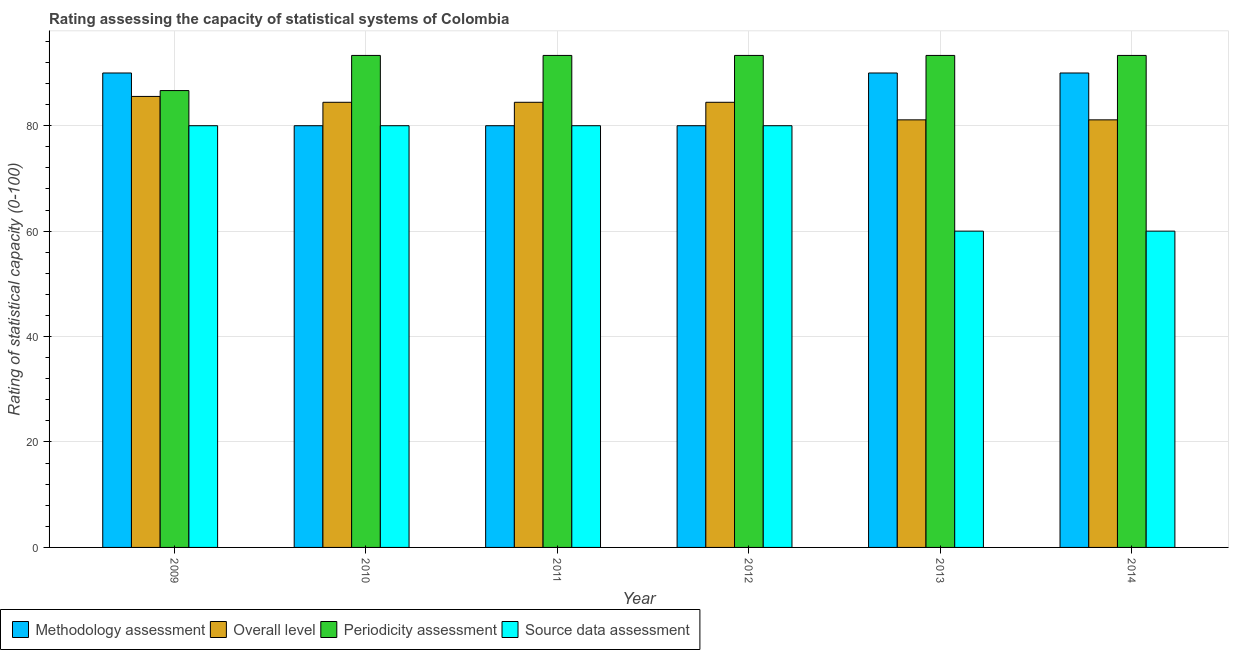How many different coloured bars are there?
Provide a short and direct response. 4. How many groups of bars are there?
Provide a succinct answer. 6. How many bars are there on the 3rd tick from the left?
Your response must be concise. 4. What is the periodicity assessment rating in 2012?
Your answer should be compact. 93.33. Across all years, what is the maximum methodology assessment rating?
Give a very brief answer. 90. Across all years, what is the minimum source data assessment rating?
Offer a very short reply. 60. In which year was the periodicity assessment rating maximum?
Ensure brevity in your answer.  2013. What is the total periodicity assessment rating in the graph?
Keep it short and to the point. 553.33. What is the difference between the overall level rating in 2009 and that in 2011?
Offer a terse response. 1.11. What is the difference between the periodicity assessment rating in 2009 and the methodology assessment rating in 2012?
Ensure brevity in your answer.  -6.67. What is the average source data assessment rating per year?
Offer a terse response. 73.33. What is the ratio of the methodology assessment rating in 2011 to that in 2012?
Your answer should be very brief. 1. Is the periodicity assessment rating in 2010 less than that in 2012?
Your response must be concise. No. Is the difference between the methodology assessment rating in 2013 and 2014 greater than the difference between the overall level rating in 2013 and 2014?
Make the answer very short. No. What is the difference between the highest and the second highest overall level rating?
Give a very brief answer. 1.11. What is the difference between the highest and the lowest periodicity assessment rating?
Make the answer very short. 6.67. In how many years, is the methodology assessment rating greater than the average methodology assessment rating taken over all years?
Provide a short and direct response. 3. Is the sum of the methodology assessment rating in 2010 and 2011 greater than the maximum periodicity assessment rating across all years?
Provide a succinct answer. Yes. Is it the case that in every year, the sum of the overall level rating and methodology assessment rating is greater than the sum of source data assessment rating and periodicity assessment rating?
Your answer should be very brief. No. What does the 1st bar from the left in 2012 represents?
Ensure brevity in your answer.  Methodology assessment. What does the 4th bar from the right in 2012 represents?
Your answer should be very brief. Methodology assessment. Is it the case that in every year, the sum of the methodology assessment rating and overall level rating is greater than the periodicity assessment rating?
Ensure brevity in your answer.  Yes. Are all the bars in the graph horizontal?
Offer a very short reply. No. What is the difference between two consecutive major ticks on the Y-axis?
Give a very brief answer. 20. Are the values on the major ticks of Y-axis written in scientific E-notation?
Provide a succinct answer. No. Does the graph contain any zero values?
Give a very brief answer. No. How many legend labels are there?
Offer a very short reply. 4. What is the title of the graph?
Offer a very short reply. Rating assessing the capacity of statistical systems of Colombia. What is the label or title of the Y-axis?
Ensure brevity in your answer.  Rating of statistical capacity (0-100). What is the Rating of statistical capacity (0-100) of Methodology assessment in 2009?
Keep it short and to the point. 90. What is the Rating of statistical capacity (0-100) of Overall level in 2009?
Offer a very short reply. 85.56. What is the Rating of statistical capacity (0-100) of Periodicity assessment in 2009?
Ensure brevity in your answer.  86.67. What is the Rating of statistical capacity (0-100) in Overall level in 2010?
Keep it short and to the point. 84.44. What is the Rating of statistical capacity (0-100) of Periodicity assessment in 2010?
Your answer should be very brief. 93.33. What is the Rating of statistical capacity (0-100) in Overall level in 2011?
Offer a very short reply. 84.44. What is the Rating of statistical capacity (0-100) in Periodicity assessment in 2011?
Offer a very short reply. 93.33. What is the Rating of statistical capacity (0-100) of Methodology assessment in 2012?
Offer a very short reply. 80. What is the Rating of statistical capacity (0-100) of Overall level in 2012?
Your answer should be compact. 84.44. What is the Rating of statistical capacity (0-100) in Periodicity assessment in 2012?
Ensure brevity in your answer.  93.33. What is the Rating of statistical capacity (0-100) of Overall level in 2013?
Make the answer very short. 81.11. What is the Rating of statistical capacity (0-100) of Periodicity assessment in 2013?
Provide a succinct answer. 93.33. What is the Rating of statistical capacity (0-100) in Source data assessment in 2013?
Make the answer very short. 60. What is the Rating of statistical capacity (0-100) of Methodology assessment in 2014?
Provide a short and direct response. 90. What is the Rating of statistical capacity (0-100) of Overall level in 2014?
Offer a terse response. 81.11. What is the Rating of statistical capacity (0-100) in Periodicity assessment in 2014?
Provide a succinct answer. 93.33. What is the Rating of statistical capacity (0-100) in Source data assessment in 2014?
Make the answer very short. 60. Across all years, what is the maximum Rating of statistical capacity (0-100) in Methodology assessment?
Offer a very short reply. 90. Across all years, what is the maximum Rating of statistical capacity (0-100) in Overall level?
Make the answer very short. 85.56. Across all years, what is the maximum Rating of statistical capacity (0-100) of Periodicity assessment?
Your answer should be compact. 93.33. Across all years, what is the minimum Rating of statistical capacity (0-100) of Methodology assessment?
Your answer should be compact. 80. Across all years, what is the minimum Rating of statistical capacity (0-100) of Overall level?
Provide a short and direct response. 81.11. Across all years, what is the minimum Rating of statistical capacity (0-100) of Periodicity assessment?
Ensure brevity in your answer.  86.67. Across all years, what is the minimum Rating of statistical capacity (0-100) of Source data assessment?
Provide a short and direct response. 60. What is the total Rating of statistical capacity (0-100) of Methodology assessment in the graph?
Make the answer very short. 510. What is the total Rating of statistical capacity (0-100) of Overall level in the graph?
Offer a terse response. 501.11. What is the total Rating of statistical capacity (0-100) in Periodicity assessment in the graph?
Ensure brevity in your answer.  553.33. What is the total Rating of statistical capacity (0-100) of Source data assessment in the graph?
Keep it short and to the point. 440. What is the difference between the Rating of statistical capacity (0-100) of Periodicity assessment in 2009 and that in 2010?
Give a very brief answer. -6.67. What is the difference between the Rating of statistical capacity (0-100) in Periodicity assessment in 2009 and that in 2011?
Provide a succinct answer. -6.67. What is the difference between the Rating of statistical capacity (0-100) of Periodicity assessment in 2009 and that in 2012?
Your answer should be compact. -6.67. What is the difference between the Rating of statistical capacity (0-100) of Source data assessment in 2009 and that in 2012?
Provide a succinct answer. 0. What is the difference between the Rating of statistical capacity (0-100) of Methodology assessment in 2009 and that in 2013?
Keep it short and to the point. 0. What is the difference between the Rating of statistical capacity (0-100) of Overall level in 2009 and that in 2013?
Ensure brevity in your answer.  4.44. What is the difference between the Rating of statistical capacity (0-100) of Periodicity assessment in 2009 and that in 2013?
Your response must be concise. -6.67. What is the difference between the Rating of statistical capacity (0-100) in Source data assessment in 2009 and that in 2013?
Your answer should be very brief. 20. What is the difference between the Rating of statistical capacity (0-100) in Methodology assessment in 2009 and that in 2014?
Your answer should be very brief. 0. What is the difference between the Rating of statistical capacity (0-100) in Overall level in 2009 and that in 2014?
Keep it short and to the point. 4.44. What is the difference between the Rating of statistical capacity (0-100) of Periodicity assessment in 2009 and that in 2014?
Your answer should be very brief. -6.67. What is the difference between the Rating of statistical capacity (0-100) of Source data assessment in 2009 and that in 2014?
Give a very brief answer. 20. What is the difference between the Rating of statistical capacity (0-100) of Source data assessment in 2010 and that in 2011?
Your answer should be compact. 0. What is the difference between the Rating of statistical capacity (0-100) of Overall level in 2010 and that in 2012?
Your response must be concise. 0. What is the difference between the Rating of statistical capacity (0-100) of Periodicity assessment in 2010 and that in 2012?
Provide a short and direct response. 0. What is the difference between the Rating of statistical capacity (0-100) in Source data assessment in 2010 and that in 2012?
Provide a succinct answer. 0. What is the difference between the Rating of statistical capacity (0-100) of Periodicity assessment in 2010 and that in 2013?
Provide a short and direct response. -0. What is the difference between the Rating of statistical capacity (0-100) of Methodology assessment in 2011 and that in 2012?
Your answer should be very brief. 0. What is the difference between the Rating of statistical capacity (0-100) of Overall level in 2011 and that in 2012?
Make the answer very short. 0. What is the difference between the Rating of statistical capacity (0-100) of Periodicity assessment in 2011 and that in 2012?
Make the answer very short. 0. What is the difference between the Rating of statistical capacity (0-100) of Periodicity assessment in 2011 and that in 2013?
Offer a very short reply. -0. What is the difference between the Rating of statistical capacity (0-100) in Source data assessment in 2011 and that in 2013?
Make the answer very short. 20. What is the difference between the Rating of statistical capacity (0-100) in Methodology assessment in 2011 and that in 2014?
Make the answer very short. -10. What is the difference between the Rating of statistical capacity (0-100) of Overall level in 2011 and that in 2014?
Provide a succinct answer. 3.33. What is the difference between the Rating of statistical capacity (0-100) in Methodology assessment in 2012 and that in 2013?
Provide a succinct answer. -10. What is the difference between the Rating of statistical capacity (0-100) of Periodicity assessment in 2012 and that in 2013?
Provide a succinct answer. -0. What is the difference between the Rating of statistical capacity (0-100) in Methodology assessment in 2012 and that in 2014?
Your response must be concise. -10. What is the difference between the Rating of statistical capacity (0-100) of Periodicity assessment in 2012 and that in 2014?
Offer a terse response. -0. What is the difference between the Rating of statistical capacity (0-100) of Overall level in 2013 and that in 2014?
Your response must be concise. 0. What is the difference between the Rating of statistical capacity (0-100) of Periodicity assessment in 2013 and that in 2014?
Make the answer very short. 0. What is the difference between the Rating of statistical capacity (0-100) in Methodology assessment in 2009 and the Rating of statistical capacity (0-100) in Overall level in 2010?
Provide a short and direct response. 5.56. What is the difference between the Rating of statistical capacity (0-100) of Methodology assessment in 2009 and the Rating of statistical capacity (0-100) of Periodicity assessment in 2010?
Give a very brief answer. -3.33. What is the difference between the Rating of statistical capacity (0-100) of Overall level in 2009 and the Rating of statistical capacity (0-100) of Periodicity assessment in 2010?
Offer a very short reply. -7.78. What is the difference between the Rating of statistical capacity (0-100) of Overall level in 2009 and the Rating of statistical capacity (0-100) of Source data assessment in 2010?
Ensure brevity in your answer.  5.56. What is the difference between the Rating of statistical capacity (0-100) in Periodicity assessment in 2009 and the Rating of statistical capacity (0-100) in Source data assessment in 2010?
Offer a very short reply. 6.67. What is the difference between the Rating of statistical capacity (0-100) in Methodology assessment in 2009 and the Rating of statistical capacity (0-100) in Overall level in 2011?
Your answer should be very brief. 5.56. What is the difference between the Rating of statistical capacity (0-100) in Overall level in 2009 and the Rating of statistical capacity (0-100) in Periodicity assessment in 2011?
Ensure brevity in your answer.  -7.78. What is the difference between the Rating of statistical capacity (0-100) in Overall level in 2009 and the Rating of statistical capacity (0-100) in Source data assessment in 2011?
Provide a succinct answer. 5.56. What is the difference between the Rating of statistical capacity (0-100) in Periodicity assessment in 2009 and the Rating of statistical capacity (0-100) in Source data assessment in 2011?
Provide a succinct answer. 6.67. What is the difference between the Rating of statistical capacity (0-100) in Methodology assessment in 2009 and the Rating of statistical capacity (0-100) in Overall level in 2012?
Your answer should be compact. 5.56. What is the difference between the Rating of statistical capacity (0-100) of Overall level in 2009 and the Rating of statistical capacity (0-100) of Periodicity assessment in 2012?
Make the answer very short. -7.78. What is the difference between the Rating of statistical capacity (0-100) in Overall level in 2009 and the Rating of statistical capacity (0-100) in Source data assessment in 2012?
Give a very brief answer. 5.56. What is the difference between the Rating of statistical capacity (0-100) in Periodicity assessment in 2009 and the Rating of statistical capacity (0-100) in Source data assessment in 2012?
Your answer should be very brief. 6.67. What is the difference between the Rating of statistical capacity (0-100) in Methodology assessment in 2009 and the Rating of statistical capacity (0-100) in Overall level in 2013?
Offer a very short reply. 8.89. What is the difference between the Rating of statistical capacity (0-100) in Methodology assessment in 2009 and the Rating of statistical capacity (0-100) in Periodicity assessment in 2013?
Your answer should be compact. -3.33. What is the difference between the Rating of statistical capacity (0-100) of Methodology assessment in 2009 and the Rating of statistical capacity (0-100) of Source data assessment in 2013?
Keep it short and to the point. 30. What is the difference between the Rating of statistical capacity (0-100) in Overall level in 2009 and the Rating of statistical capacity (0-100) in Periodicity assessment in 2013?
Your answer should be very brief. -7.78. What is the difference between the Rating of statistical capacity (0-100) in Overall level in 2009 and the Rating of statistical capacity (0-100) in Source data assessment in 2013?
Provide a succinct answer. 25.56. What is the difference between the Rating of statistical capacity (0-100) of Periodicity assessment in 2009 and the Rating of statistical capacity (0-100) of Source data assessment in 2013?
Your answer should be compact. 26.67. What is the difference between the Rating of statistical capacity (0-100) in Methodology assessment in 2009 and the Rating of statistical capacity (0-100) in Overall level in 2014?
Provide a succinct answer. 8.89. What is the difference between the Rating of statistical capacity (0-100) in Methodology assessment in 2009 and the Rating of statistical capacity (0-100) in Source data assessment in 2014?
Give a very brief answer. 30. What is the difference between the Rating of statistical capacity (0-100) in Overall level in 2009 and the Rating of statistical capacity (0-100) in Periodicity assessment in 2014?
Give a very brief answer. -7.78. What is the difference between the Rating of statistical capacity (0-100) of Overall level in 2009 and the Rating of statistical capacity (0-100) of Source data assessment in 2014?
Give a very brief answer. 25.56. What is the difference between the Rating of statistical capacity (0-100) in Periodicity assessment in 2009 and the Rating of statistical capacity (0-100) in Source data assessment in 2014?
Offer a very short reply. 26.67. What is the difference between the Rating of statistical capacity (0-100) of Methodology assessment in 2010 and the Rating of statistical capacity (0-100) of Overall level in 2011?
Give a very brief answer. -4.44. What is the difference between the Rating of statistical capacity (0-100) of Methodology assessment in 2010 and the Rating of statistical capacity (0-100) of Periodicity assessment in 2011?
Your answer should be very brief. -13.33. What is the difference between the Rating of statistical capacity (0-100) in Methodology assessment in 2010 and the Rating of statistical capacity (0-100) in Source data assessment in 2011?
Ensure brevity in your answer.  0. What is the difference between the Rating of statistical capacity (0-100) of Overall level in 2010 and the Rating of statistical capacity (0-100) of Periodicity assessment in 2011?
Make the answer very short. -8.89. What is the difference between the Rating of statistical capacity (0-100) in Overall level in 2010 and the Rating of statistical capacity (0-100) in Source data assessment in 2011?
Offer a terse response. 4.44. What is the difference between the Rating of statistical capacity (0-100) of Periodicity assessment in 2010 and the Rating of statistical capacity (0-100) of Source data assessment in 2011?
Keep it short and to the point. 13.33. What is the difference between the Rating of statistical capacity (0-100) in Methodology assessment in 2010 and the Rating of statistical capacity (0-100) in Overall level in 2012?
Ensure brevity in your answer.  -4.44. What is the difference between the Rating of statistical capacity (0-100) of Methodology assessment in 2010 and the Rating of statistical capacity (0-100) of Periodicity assessment in 2012?
Your answer should be compact. -13.33. What is the difference between the Rating of statistical capacity (0-100) of Methodology assessment in 2010 and the Rating of statistical capacity (0-100) of Source data assessment in 2012?
Offer a terse response. 0. What is the difference between the Rating of statistical capacity (0-100) in Overall level in 2010 and the Rating of statistical capacity (0-100) in Periodicity assessment in 2012?
Your answer should be very brief. -8.89. What is the difference between the Rating of statistical capacity (0-100) in Overall level in 2010 and the Rating of statistical capacity (0-100) in Source data assessment in 2012?
Give a very brief answer. 4.44. What is the difference between the Rating of statistical capacity (0-100) of Periodicity assessment in 2010 and the Rating of statistical capacity (0-100) of Source data assessment in 2012?
Provide a short and direct response. 13.33. What is the difference between the Rating of statistical capacity (0-100) of Methodology assessment in 2010 and the Rating of statistical capacity (0-100) of Overall level in 2013?
Your answer should be very brief. -1.11. What is the difference between the Rating of statistical capacity (0-100) in Methodology assessment in 2010 and the Rating of statistical capacity (0-100) in Periodicity assessment in 2013?
Offer a very short reply. -13.33. What is the difference between the Rating of statistical capacity (0-100) of Methodology assessment in 2010 and the Rating of statistical capacity (0-100) of Source data assessment in 2013?
Offer a terse response. 20. What is the difference between the Rating of statistical capacity (0-100) in Overall level in 2010 and the Rating of statistical capacity (0-100) in Periodicity assessment in 2013?
Your response must be concise. -8.89. What is the difference between the Rating of statistical capacity (0-100) in Overall level in 2010 and the Rating of statistical capacity (0-100) in Source data assessment in 2013?
Your answer should be compact. 24.44. What is the difference between the Rating of statistical capacity (0-100) in Periodicity assessment in 2010 and the Rating of statistical capacity (0-100) in Source data assessment in 2013?
Offer a terse response. 33.33. What is the difference between the Rating of statistical capacity (0-100) in Methodology assessment in 2010 and the Rating of statistical capacity (0-100) in Overall level in 2014?
Ensure brevity in your answer.  -1.11. What is the difference between the Rating of statistical capacity (0-100) in Methodology assessment in 2010 and the Rating of statistical capacity (0-100) in Periodicity assessment in 2014?
Your response must be concise. -13.33. What is the difference between the Rating of statistical capacity (0-100) in Overall level in 2010 and the Rating of statistical capacity (0-100) in Periodicity assessment in 2014?
Provide a succinct answer. -8.89. What is the difference between the Rating of statistical capacity (0-100) in Overall level in 2010 and the Rating of statistical capacity (0-100) in Source data assessment in 2014?
Make the answer very short. 24.44. What is the difference between the Rating of statistical capacity (0-100) of Periodicity assessment in 2010 and the Rating of statistical capacity (0-100) of Source data assessment in 2014?
Provide a short and direct response. 33.33. What is the difference between the Rating of statistical capacity (0-100) in Methodology assessment in 2011 and the Rating of statistical capacity (0-100) in Overall level in 2012?
Your response must be concise. -4.44. What is the difference between the Rating of statistical capacity (0-100) in Methodology assessment in 2011 and the Rating of statistical capacity (0-100) in Periodicity assessment in 2012?
Your answer should be very brief. -13.33. What is the difference between the Rating of statistical capacity (0-100) of Methodology assessment in 2011 and the Rating of statistical capacity (0-100) of Source data assessment in 2012?
Make the answer very short. 0. What is the difference between the Rating of statistical capacity (0-100) of Overall level in 2011 and the Rating of statistical capacity (0-100) of Periodicity assessment in 2012?
Offer a terse response. -8.89. What is the difference between the Rating of statistical capacity (0-100) of Overall level in 2011 and the Rating of statistical capacity (0-100) of Source data assessment in 2012?
Offer a very short reply. 4.44. What is the difference between the Rating of statistical capacity (0-100) in Periodicity assessment in 2011 and the Rating of statistical capacity (0-100) in Source data assessment in 2012?
Make the answer very short. 13.33. What is the difference between the Rating of statistical capacity (0-100) of Methodology assessment in 2011 and the Rating of statistical capacity (0-100) of Overall level in 2013?
Ensure brevity in your answer.  -1.11. What is the difference between the Rating of statistical capacity (0-100) in Methodology assessment in 2011 and the Rating of statistical capacity (0-100) in Periodicity assessment in 2013?
Your answer should be very brief. -13.33. What is the difference between the Rating of statistical capacity (0-100) of Methodology assessment in 2011 and the Rating of statistical capacity (0-100) of Source data assessment in 2013?
Provide a short and direct response. 20. What is the difference between the Rating of statistical capacity (0-100) in Overall level in 2011 and the Rating of statistical capacity (0-100) in Periodicity assessment in 2013?
Your answer should be very brief. -8.89. What is the difference between the Rating of statistical capacity (0-100) of Overall level in 2011 and the Rating of statistical capacity (0-100) of Source data assessment in 2013?
Offer a very short reply. 24.44. What is the difference between the Rating of statistical capacity (0-100) of Periodicity assessment in 2011 and the Rating of statistical capacity (0-100) of Source data assessment in 2013?
Make the answer very short. 33.33. What is the difference between the Rating of statistical capacity (0-100) of Methodology assessment in 2011 and the Rating of statistical capacity (0-100) of Overall level in 2014?
Your response must be concise. -1.11. What is the difference between the Rating of statistical capacity (0-100) of Methodology assessment in 2011 and the Rating of statistical capacity (0-100) of Periodicity assessment in 2014?
Offer a terse response. -13.33. What is the difference between the Rating of statistical capacity (0-100) of Methodology assessment in 2011 and the Rating of statistical capacity (0-100) of Source data assessment in 2014?
Provide a succinct answer. 20. What is the difference between the Rating of statistical capacity (0-100) in Overall level in 2011 and the Rating of statistical capacity (0-100) in Periodicity assessment in 2014?
Make the answer very short. -8.89. What is the difference between the Rating of statistical capacity (0-100) in Overall level in 2011 and the Rating of statistical capacity (0-100) in Source data assessment in 2014?
Provide a succinct answer. 24.44. What is the difference between the Rating of statistical capacity (0-100) of Periodicity assessment in 2011 and the Rating of statistical capacity (0-100) of Source data assessment in 2014?
Keep it short and to the point. 33.33. What is the difference between the Rating of statistical capacity (0-100) of Methodology assessment in 2012 and the Rating of statistical capacity (0-100) of Overall level in 2013?
Your answer should be very brief. -1.11. What is the difference between the Rating of statistical capacity (0-100) of Methodology assessment in 2012 and the Rating of statistical capacity (0-100) of Periodicity assessment in 2013?
Give a very brief answer. -13.33. What is the difference between the Rating of statistical capacity (0-100) in Methodology assessment in 2012 and the Rating of statistical capacity (0-100) in Source data assessment in 2013?
Provide a succinct answer. 20. What is the difference between the Rating of statistical capacity (0-100) in Overall level in 2012 and the Rating of statistical capacity (0-100) in Periodicity assessment in 2013?
Your answer should be very brief. -8.89. What is the difference between the Rating of statistical capacity (0-100) in Overall level in 2012 and the Rating of statistical capacity (0-100) in Source data assessment in 2013?
Make the answer very short. 24.44. What is the difference between the Rating of statistical capacity (0-100) of Periodicity assessment in 2012 and the Rating of statistical capacity (0-100) of Source data assessment in 2013?
Make the answer very short. 33.33. What is the difference between the Rating of statistical capacity (0-100) of Methodology assessment in 2012 and the Rating of statistical capacity (0-100) of Overall level in 2014?
Offer a very short reply. -1.11. What is the difference between the Rating of statistical capacity (0-100) in Methodology assessment in 2012 and the Rating of statistical capacity (0-100) in Periodicity assessment in 2014?
Keep it short and to the point. -13.33. What is the difference between the Rating of statistical capacity (0-100) in Overall level in 2012 and the Rating of statistical capacity (0-100) in Periodicity assessment in 2014?
Provide a succinct answer. -8.89. What is the difference between the Rating of statistical capacity (0-100) of Overall level in 2012 and the Rating of statistical capacity (0-100) of Source data assessment in 2014?
Provide a succinct answer. 24.44. What is the difference between the Rating of statistical capacity (0-100) in Periodicity assessment in 2012 and the Rating of statistical capacity (0-100) in Source data assessment in 2014?
Give a very brief answer. 33.33. What is the difference between the Rating of statistical capacity (0-100) of Methodology assessment in 2013 and the Rating of statistical capacity (0-100) of Overall level in 2014?
Provide a succinct answer. 8.89. What is the difference between the Rating of statistical capacity (0-100) in Overall level in 2013 and the Rating of statistical capacity (0-100) in Periodicity assessment in 2014?
Your answer should be compact. -12.22. What is the difference between the Rating of statistical capacity (0-100) of Overall level in 2013 and the Rating of statistical capacity (0-100) of Source data assessment in 2014?
Offer a very short reply. 21.11. What is the difference between the Rating of statistical capacity (0-100) of Periodicity assessment in 2013 and the Rating of statistical capacity (0-100) of Source data assessment in 2014?
Your answer should be very brief. 33.33. What is the average Rating of statistical capacity (0-100) of Methodology assessment per year?
Keep it short and to the point. 85. What is the average Rating of statistical capacity (0-100) of Overall level per year?
Your answer should be very brief. 83.52. What is the average Rating of statistical capacity (0-100) in Periodicity assessment per year?
Provide a succinct answer. 92.22. What is the average Rating of statistical capacity (0-100) in Source data assessment per year?
Offer a very short reply. 73.33. In the year 2009, what is the difference between the Rating of statistical capacity (0-100) in Methodology assessment and Rating of statistical capacity (0-100) in Overall level?
Provide a succinct answer. 4.44. In the year 2009, what is the difference between the Rating of statistical capacity (0-100) in Methodology assessment and Rating of statistical capacity (0-100) in Periodicity assessment?
Ensure brevity in your answer.  3.33. In the year 2009, what is the difference between the Rating of statistical capacity (0-100) in Methodology assessment and Rating of statistical capacity (0-100) in Source data assessment?
Your answer should be very brief. 10. In the year 2009, what is the difference between the Rating of statistical capacity (0-100) of Overall level and Rating of statistical capacity (0-100) of Periodicity assessment?
Your answer should be compact. -1.11. In the year 2009, what is the difference between the Rating of statistical capacity (0-100) of Overall level and Rating of statistical capacity (0-100) of Source data assessment?
Keep it short and to the point. 5.56. In the year 2009, what is the difference between the Rating of statistical capacity (0-100) in Periodicity assessment and Rating of statistical capacity (0-100) in Source data assessment?
Your response must be concise. 6.67. In the year 2010, what is the difference between the Rating of statistical capacity (0-100) of Methodology assessment and Rating of statistical capacity (0-100) of Overall level?
Provide a succinct answer. -4.44. In the year 2010, what is the difference between the Rating of statistical capacity (0-100) in Methodology assessment and Rating of statistical capacity (0-100) in Periodicity assessment?
Keep it short and to the point. -13.33. In the year 2010, what is the difference between the Rating of statistical capacity (0-100) in Overall level and Rating of statistical capacity (0-100) in Periodicity assessment?
Ensure brevity in your answer.  -8.89. In the year 2010, what is the difference between the Rating of statistical capacity (0-100) of Overall level and Rating of statistical capacity (0-100) of Source data assessment?
Provide a short and direct response. 4.44. In the year 2010, what is the difference between the Rating of statistical capacity (0-100) of Periodicity assessment and Rating of statistical capacity (0-100) of Source data assessment?
Offer a terse response. 13.33. In the year 2011, what is the difference between the Rating of statistical capacity (0-100) in Methodology assessment and Rating of statistical capacity (0-100) in Overall level?
Your response must be concise. -4.44. In the year 2011, what is the difference between the Rating of statistical capacity (0-100) of Methodology assessment and Rating of statistical capacity (0-100) of Periodicity assessment?
Keep it short and to the point. -13.33. In the year 2011, what is the difference between the Rating of statistical capacity (0-100) of Methodology assessment and Rating of statistical capacity (0-100) of Source data assessment?
Your answer should be very brief. 0. In the year 2011, what is the difference between the Rating of statistical capacity (0-100) of Overall level and Rating of statistical capacity (0-100) of Periodicity assessment?
Your answer should be compact. -8.89. In the year 2011, what is the difference between the Rating of statistical capacity (0-100) in Overall level and Rating of statistical capacity (0-100) in Source data assessment?
Give a very brief answer. 4.44. In the year 2011, what is the difference between the Rating of statistical capacity (0-100) in Periodicity assessment and Rating of statistical capacity (0-100) in Source data assessment?
Keep it short and to the point. 13.33. In the year 2012, what is the difference between the Rating of statistical capacity (0-100) in Methodology assessment and Rating of statistical capacity (0-100) in Overall level?
Offer a terse response. -4.44. In the year 2012, what is the difference between the Rating of statistical capacity (0-100) in Methodology assessment and Rating of statistical capacity (0-100) in Periodicity assessment?
Make the answer very short. -13.33. In the year 2012, what is the difference between the Rating of statistical capacity (0-100) of Methodology assessment and Rating of statistical capacity (0-100) of Source data assessment?
Offer a very short reply. 0. In the year 2012, what is the difference between the Rating of statistical capacity (0-100) of Overall level and Rating of statistical capacity (0-100) of Periodicity assessment?
Provide a succinct answer. -8.89. In the year 2012, what is the difference between the Rating of statistical capacity (0-100) in Overall level and Rating of statistical capacity (0-100) in Source data assessment?
Your answer should be very brief. 4.44. In the year 2012, what is the difference between the Rating of statistical capacity (0-100) in Periodicity assessment and Rating of statistical capacity (0-100) in Source data assessment?
Provide a succinct answer. 13.33. In the year 2013, what is the difference between the Rating of statistical capacity (0-100) of Methodology assessment and Rating of statistical capacity (0-100) of Overall level?
Your response must be concise. 8.89. In the year 2013, what is the difference between the Rating of statistical capacity (0-100) in Methodology assessment and Rating of statistical capacity (0-100) in Periodicity assessment?
Ensure brevity in your answer.  -3.33. In the year 2013, what is the difference between the Rating of statistical capacity (0-100) of Overall level and Rating of statistical capacity (0-100) of Periodicity assessment?
Offer a very short reply. -12.22. In the year 2013, what is the difference between the Rating of statistical capacity (0-100) in Overall level and Rating of statistical capacity (0-100) in Source data assessment?
Provide a short and direct response. 21.11. In the year 2013, what is the difference between the Rating of statistical capacity (0-100) of Periodicity assessment and Rating of statistical capacity (0-100) of Source data assessment?
Provide a short and direct response. 33.33. In the year 2014, what is the difference between the Rating of statistical capacity (0-100) in Methodology assessment and Rating of statistical capacity (0-100) in Overall level?
Ensure brevity in your answer.  8.89. In the year 2014, what is the difference between the Rating of statistical capacity (0-100) of Methodology assessment and Rating of statistical capacity (0-100) of Periodicity assessment?
Your response must be concise. -3.33. In the year 2014, what is the difference between the Rating of statistical capacity (0-100) of Overall level and Rating of statistical capacity (0-100) of Periodicity assessment?
Your response must be concise. -12.22. In the year 2014, what is the difference between the Rating of statistical capacity (0-100) of Overall level and Rating of statistical capacity (0-100) of Source data assessment?
Ensure brevity in your answer.  21.11. In the year 2014, what is the difference between the Rating of statistical capacity (0-100) of Periodicity assessment and Rating of statistical capacity (0-100) of Source data assessment?
Your response must be concise. 33.33. What is the ratio of the Rating of statistical capacity (0-100) of Overall level in 2009 to that in 2010?
Your response must be concise. 1.01. What is the ratio of the Rating of statistical capacity (0-100) of Overall level in 2009 to that in 2011?
Provide a short and direct response. 1.01. What is the ratio of the Rating of statistical capacity (0-100) in Overall level in 2009 to that in 2012?
Keep it short and to the point. 1.01. What is the ratio of the Rating of statistical capacity (0-100) in Overall level in 2009 to that in 2013?
Keep it short and to the point. 1.05. What is the ratio of the Rating of statistical capacity (0-100) of Periodicity assessment in 2009 to that in 2013?
Your answer should be compact. 0.93. What is the ratio of the Rating of statistical capacity (0-100) of Overall level in 2009 to that in 2014?
Your response must be concise. 1.05. What is the ratio of the Rating of statistical capacity (0-100) of Periodicity assessment in 2009 to that in 2014?
Keep it short and to the point. 0.93. What is the ratio of the Rating of statistical capacity (0-100) of Overall level in 2010 to that in 2011?
Provide a short and direct response. 1. What is the ratio of the Rating of statistical capacity (0-100) of Periodicity assessment in 2010 to that in 2011?
Your answer should be compact. 1. What is the ratio of the Rating of statistical capacity (0-100) of Methodology assessment in 2010 to that in 2012?
Your response must be concise. 1. What is the ratio of the Rating of statistical capacity (0-100) in Overall level in 2010 to that in 2012?
Keep it short and to the point. 1. What is the ratio of the Rating of statistical capacity (0-100) of Periodicity assessment in 2010 to that in 2012?
Provide a succinct answer. 1. What is the ratio of the Rating of statistical capacity (0-100) in Overall level in 2010 to that in 2013?
Give a very brief answer. 1.04. What is the ratio of the Rating of statistical capacity (0-100) in Source data assessment in 2010 to that in 2013?
Ensure brevity in your answer.  1.33. What is the ratio of the Rating of statistical capacity (0-100) in Methodology assessment in 2010 to that in 2014?
Make the answer very short. 0.89. What is the ratio of the Rating of statistical capacity (0-100) of Overall level in 2010 to that in 2014?
Your answer should be very brief. 1.04. What is the ratio of the Rating of statistical capacity (0-100) in Source data assessment in 2010 to that in 2014?
Make the answer very short. 1.33. What is the ratio of the Rating of statistical capacity (0-100) in Source data assessment in 2011 to that in 2012?
Your answer should be compact. 1. What is the ratio of the Rating of statistical capacity (0-100) in Overall level in 2011 to that in 2013?
Offer a very short reply. 1.04. What is the ratio of the Rating of statistical capacity (0-100) of Source data assessment in 2011 to that in 2013?
Give a very brief answer. 1.33. What is the ratio of the Rating of statistical capacity (0-100) of Overall level in 2011 to that in 2014?
Provide a short and direct response. 1.04. What is the ratio of the Rating of statistical capacity (0-100) in Source data assessment in 2011 to that in 2014?
Your response must be concise. 1.33. What is the ratio of the Rating of statistical capacity (0-100) of Overall level in 2012 to that in 2013?
Offer a terse response. 1.04. What is the ratio of the Rating of statistical capacity (0-100) in Source data assessment in 2012 to that in 2013?
Your answer should be compact. 1.33. What is the ratio of the Rating of statistical capacity (0-100) in Overall level in 2012 to that in 2014?
Provide a short and direct response. 1.04. What is the ratio of the Rating of statistical capacity (0-100) of Periodicity assessment in 2012 to that in 2014?
Offer a very short reply. 1. What is the ratio of the Rating of statistical capacity (0-100) of Source data assessment in 2012 to that in 2014?
Your response must be concise. 1.33. What is the ratio of the Rating of statistical capacity (0-100) of Methodology assessment in 2013 to that in 2014?
Ensure brevity in your answer.  1. What is the ratio of the Rating of statistical capacity (0-100) of Periodicity assessment in 2013 to that in 2014?
Make the answer very short. 1. What is the difference between the highest and the second highest Rating of statistical capacity (0-100) of Periodicity assessment?
Offer a terse response. 0. What is the difference between the highest and the lowest Rating of statistical capacity (0-100) of Methodology assessment?
Offer a very short reply. 10. What is the difference between the highest and the lowest Rating of statistical capacity (0-100) in Overall level?
Your response must be concise. 4.44. What is the difference between the highest and the lowest Rating of statistical capacity (0-100) in Periodicity assessment?
Offer a terse response. 6.67. What is the difference between the highest and the lowest Rating of statistical capacity (0-100) of Source data assessment?
Your answer should be compact. 20. 